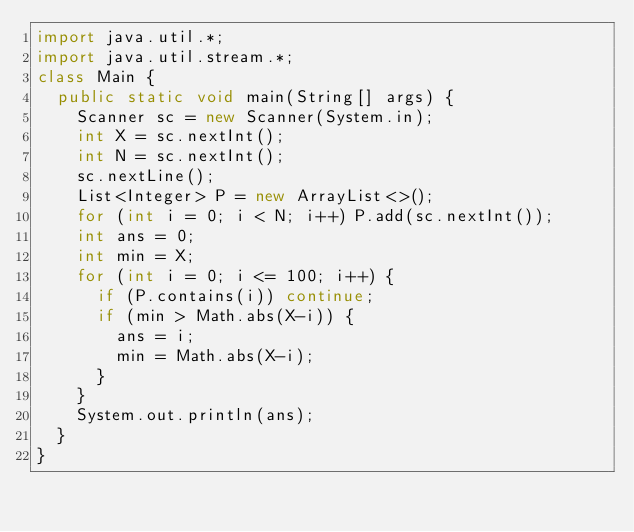Convert code to text. <code><loc_0><loc_0><loc_500><loc_500><_Java_>import java.util.*;
import java.util.stream.*;
class Main {
  public static void main(String[] args) {
    Scanner sc = new Scanner(System.in);
    int X = sc.nextInt();
    int N = sc.nextInt();
    sc.nextLine();
    List<Integer> P = new ArrayList<>();
    for (int i = 0; i < N; i++) P.add(sc.nextInt());
    int ans = 0;
    int min = X;
    for (int i = 0; i <= 100; i++) {
      if (P.contains(i)) continue;
      if (min > Math.abs(X-i)) {
        ans = i;
        min = Math.abs(X-i);
      }
    }
    System.out.println(ans);
  }
}</code> 